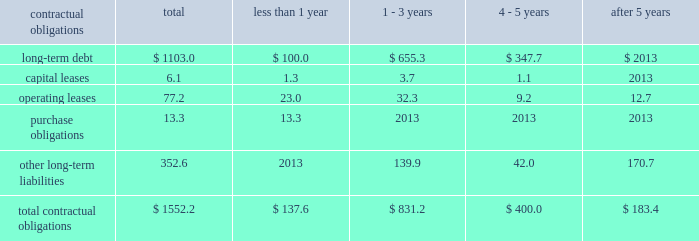Z i m m e r h o l d i n g s , i n c .
A n d s u b s i d i a r i e s 2 0 0 3 f o r m 1 0 - k contractual obligations the company has entered into contracts with various third parties in the normal course of business which will require future payments .
The table illustrates the company 2019s contractual obligations : than 1 - 3 4 - 5 after contractual obligations total 1 year years years 5 years .
Critical accounting estimates the financial results of the company are affected by the income taxes 2013 the company estimates income selection and application of accounting policies and methods .
Tax expense and income tax liabilities and assets by taxable significant accounting policies which require management 2019s jurisdiction .
Realization of deferred tax assets in each taxable judgment are discussed below .
Jurisdiction is dependent on the company 2019s ability to generate future taxable income sufficient to realize the excess inventory and instruments 2013 the company benefits .
The company evaluates deferred tax assets on must determine as of each balance sheet date how much , if an ongoing basis and provides valuation allowances if it is any , of its inventory may ultimately prove to be unsaleable or determined to be 2018 2018more likely than not 2019 2019 that the deferred unsaleable at its carrying cost .
Similarly , the company must tax benefit will not be realized .
Federal income taxes are also determine if instruments on hand will be put to provided on the portion of the income of foreign subsidiaries productive use or remain undeployed as a result of excess that is expected to be remitted to the u.s .
The company supply .
Reserves are established to effectively adjust operates within numerous taxing jurisdictions .
The company inventory and instruments to net realizable value .
To is subject to regulatory review or audit in virtually all of determine the appropriate level of reserves , the company those jurisdictions and those reviews and audits may require evaluates current stock levels in relation to historical and extended periods of time to resolve .
The company makes use expected patterns of demand for all of its products and of all available information and makes reasoned judgments instrument systems and components .
The basis for the regarding matters requiring interpretation in establishing determination is generally the same for all inventory and tax expense , liabilities and reserves .
The company believes instrument items and categories except for work-in-progress adequate provisions exist for income taxes for all periods inventory , which is recorded at cost .
Obsolete or and jurisdictions subject to review or audit .
Discontinued items are generally destroyed and completely written off .
Management evaluates the need for changes to commitments and contingencies 2013 accruals for valuation reserves based on market conditions , competitive product liability and other claims are established with offerings and other factors on a regular basis .
Centerpulse internal and external counsel based on current information historically applied a similar conceptual framework in and historical settlement information for claims , related fees estimating market value of excess inventory and instruments and for claims incurred but not reported .
An actuarial model under international financial reporting standards and is used by the company to assist management in determining u.s .
Generally accepted accounting principles .
Within that an appropriate level of accruals for product liability claims .
Framework , zimmer and centerpulse differed however , in historical patterns of claim loss development over time are certain respects , to their approaches to such estimation .
Statistically analyzed to arrive at factors which are then following the acquisition , the company determined that a applied to loss estimates in the actuarial model .
The amounts consistent approach is necessary to maintaining effective established represent management 2019s best estimate of the control over financial reporting .
Consideration was given to ultimate costs that it will incur under the various both approaches and the company established a common contingencies .
Estimation technique taking both prior approaches into account .
This change in estimate resulted in a charge to earnings of $ 3.0 million after tax in the fourth quarter .
Such change is not considered material to the company 2019s financial position , results of operations or cash flows. .
What percent of total contractual obligations is comprised of operating leases? 
Computations: (77.2 / 1552.2)
Answer: 0.04974. 